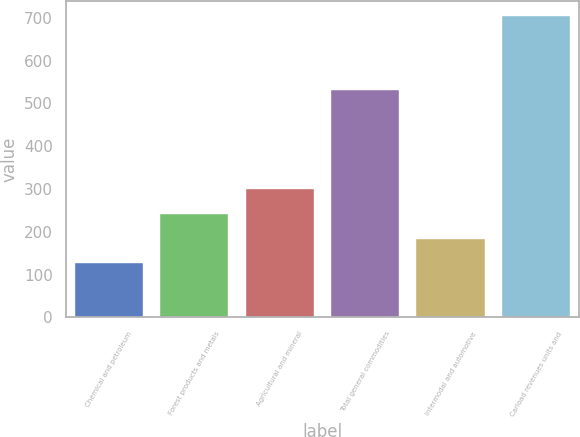<chart> <loc_0><loc_0><loc_500><loc_500><bar_chart><fcel>Chemical and petroleum<fcel>Forest products and metals<fcel>Agricultural and mineral<fcel>Total general commodities<fcel>Intermodal and automotive<fcel>Carload revenues units and<nl><fcel>126.5<fcel>242.18<fcel>300.02<fcel>531.9<fcel>184.34<fcel>704.9<nl></chart> 